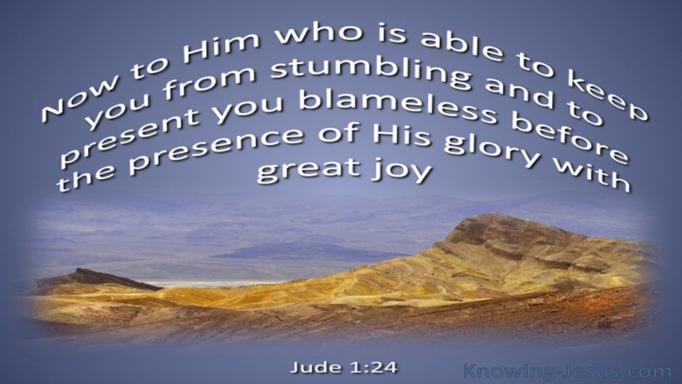What is the main message of Jude 1:24? Jude 1:24 highlights the divine promise and capability of God to not only prevent us from sinning but also to guide us towards His presence without fault and with immense joy. This sentence encapsulates a core aspect of Christian faith where the believer's journey towards salvation is secured and joyously realized by God's grace and guardianship. 